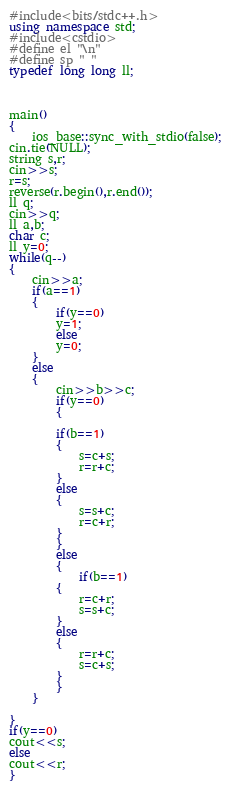<code> <loc_0><loc_0><loc_500><loc_500><_C++_>#include<bits/stdc++.h>
using namespace std;
#include<cstdio>
#define el "\n"
#define sp " "
typedef long long ll;



main()
{
	ios_base::sync_with_stdio(false);
cin.tie(NULL);
string s,r;
cin>>s;
r=s;
reverse(r.begin(),r.end());
ll q;
cin>>q;
ll a,b;
char c;
ll y=0;
while(q--)
{
	cin>>a;
	if(a==1)
	{
		if(y==0)
		y=1;
		else
		y=0;
	}
	else
	{
		cin>>b>>c;
		if(y==0)
		{
		
		if(b==1)
		{
			s=c+s;
			r=r+c;
		}
		else
		{
			s=s+c;
			r=c+r;
		}
		}
		else
		{
			if(b==1)
		{
			r=c+r;
			s=s+c;
		}
		else
		{
			r=r+c;
			s=c+s;
		}
		}
	}
	
}
if(y==0)
cout<<s;
else
cout<<r;
}</code> 